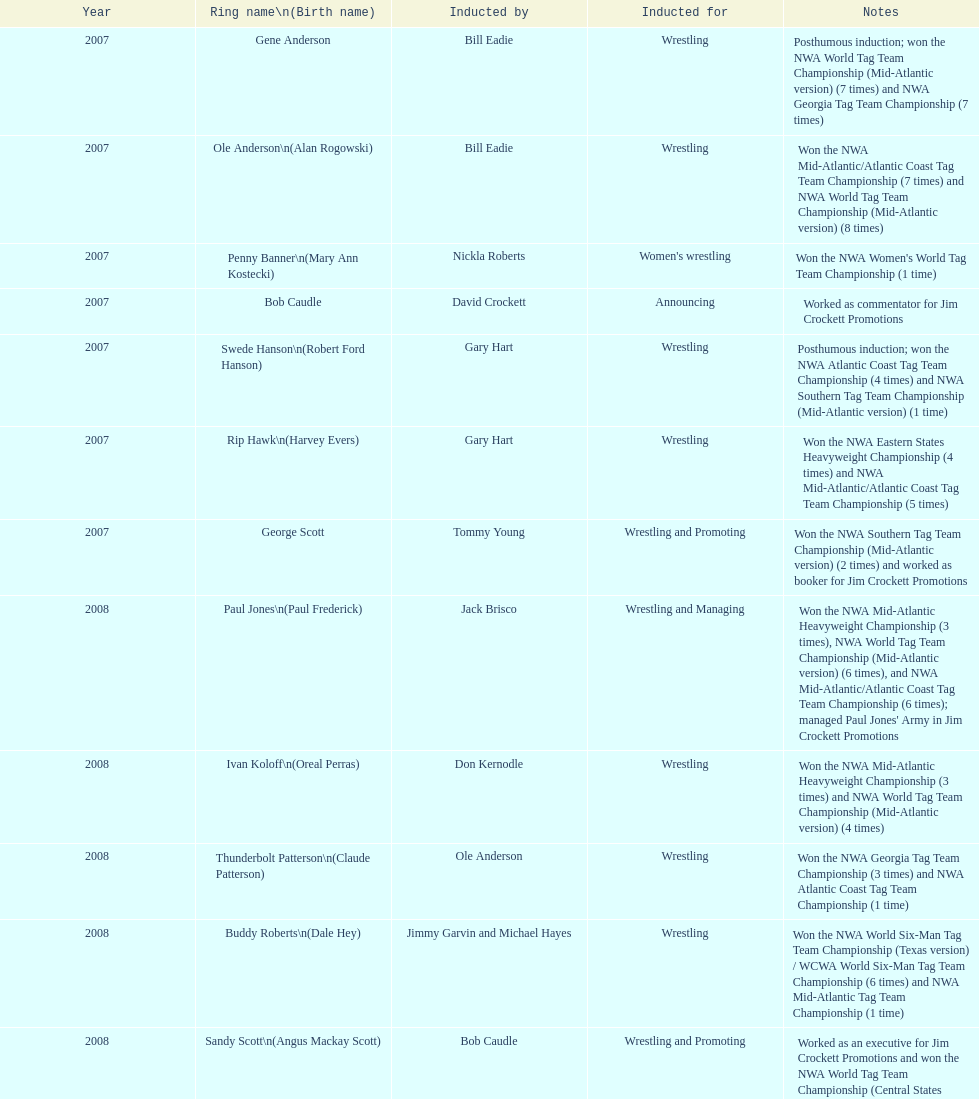Who was enrolled after royal? Lance Russell. 